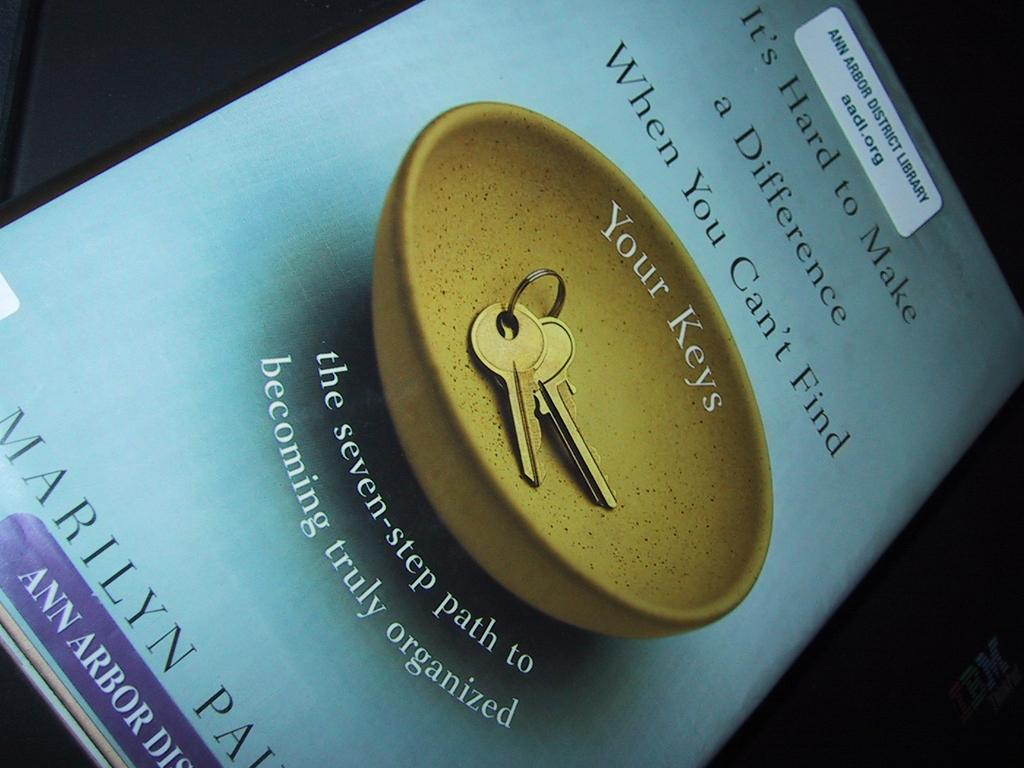Provide a one-sentence caption for the provided image. A book from the library about how to become organized. 